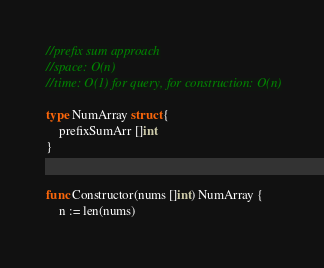Convert code to text. <code><loc_0><loc_0><loc_500><loc_500><_Go_>//prefix sum approach
//space: O(n)
//time: O(1) for query, for construction: O(n)

type NumArray struct {
    prefixSumArr []int
}


func Constructor(nums []int) NumArray {
    n := len(nums)</code> 